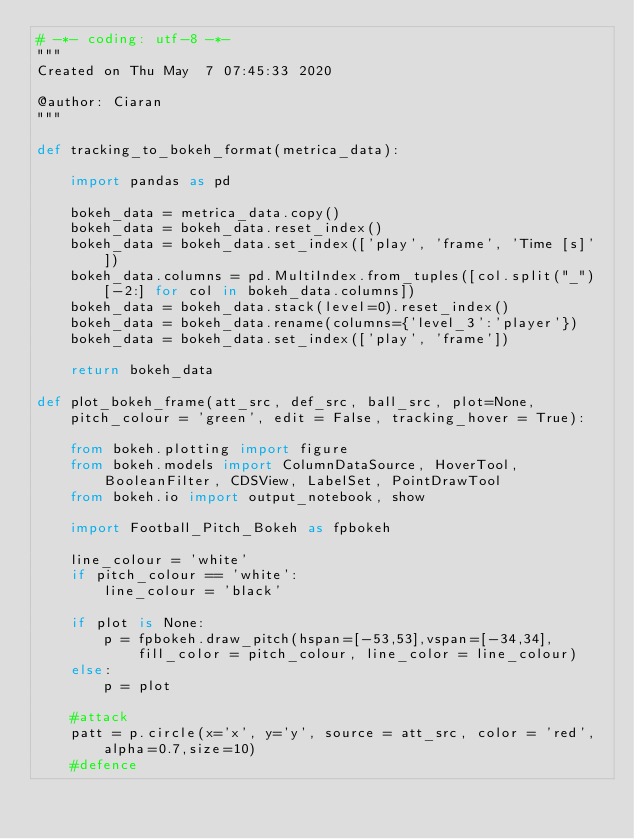<code> <loc_0><loc_0><loc_500><loc_500><_Python_># -*- coding: utf-8 -*-
"""
Created on Thu May  7 07:45:33 2020

@author: Ciaran
"""

def tracking_to_bokeh_format(metrica_data):
    
    import pandas as pd
    
    bokeh_data = metrica_data.copy()
    bokeh_data = bokeh_data.reset_index()
    bokeh_data = bokeh_data.set_index(['play', 'frame', 'Time [s]'])
    bokeh_data.columns = pd.MultiIndex.from_tuples([col.split("_")[-2:] for col in bokeh_data.columns])
    bokeh_data = bokeh_data.stack(level=0).reset_index()
    bokeh_data = bokeh_data.rename(columns={'level_3':'player'})
    bokeh_data = bokeh_data.set_index(['play', 'frame'])
    
    return bokeh_data

def plot_bokeh_frame(att_src, def_src, ball_src, plot=None, pitch_colour = 'green', edit = False, tracking_hover = True):
    
    from bokeh.plotting import figure 
    from bokeh.models import ColumnDataSource, HoverTool, BooleanFilter, CDSView, LabelSet, PointDrawTool
    from bokeh.io import output_notebook, show
    
    import Football_Pitch_Bokeh as fpbokeh
    
    line_colour = 'white'
    if pitch_colour == 'white':
        line_colour = 'black'
   
    if plot is None:
        p = fpbokeh.draw_pitch(hspan=[-53,53],vspan=[-34,34], fill_color = pitch_colour, line_color = line_colour)
    else:
        p = plot
    
    #attack
    patt = p.circle(x='x', y='y', source = att_src, color = 'red', alpha=0.7,size=10)
    #defence</code> 